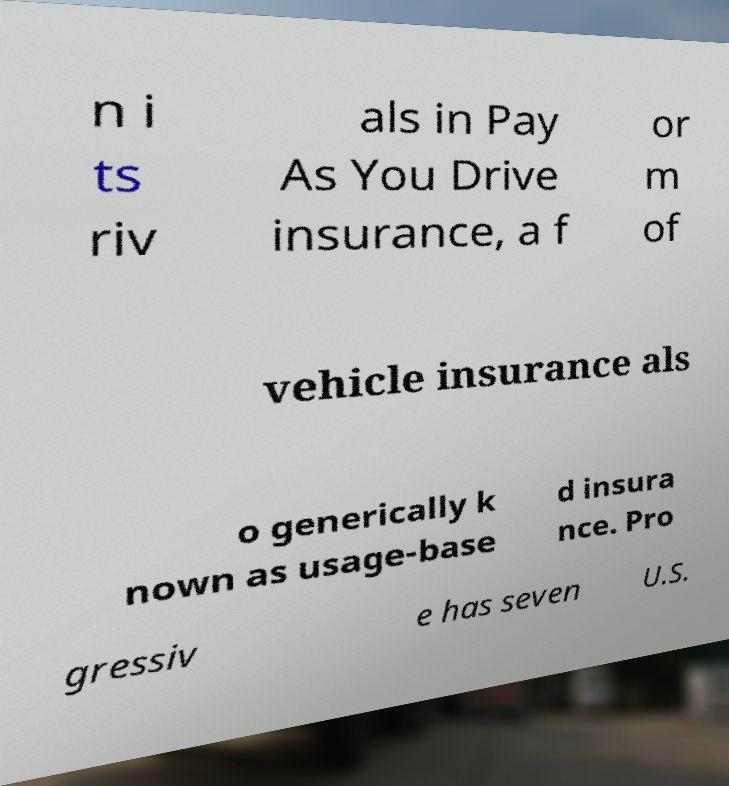What messages or text are displayed in this image? I need them in a readable, typed format. n i ts riv als in Pay As You Drive insurance, a f or m of vehicle insurance als o generically k nown as usage-base d insura nce. Pro gressiv e has seven U.S. 